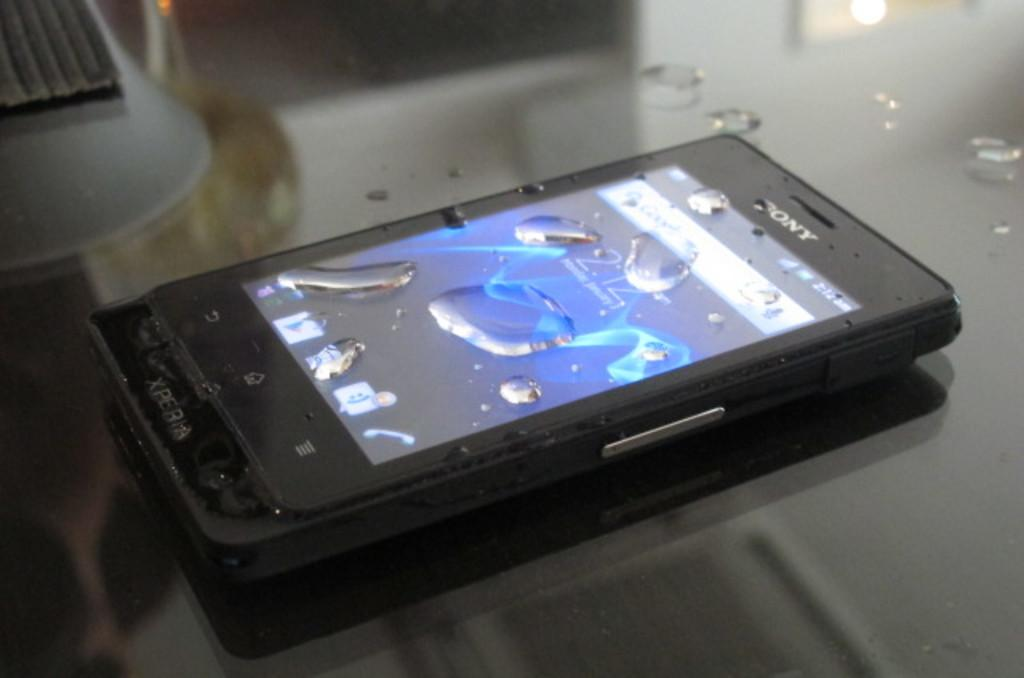What electronic device is visible in the image? There is a mobile phone in the image. Where is the mobile phone placed? The mobile phone is on a glass table. What can be seen on the surface of the mobile phone? There are droplets of water on the mobile phone. Can you describe the object on the left side top of the image? The clarity of the object is uncertain, so it is difficult to provide a detailed description. What arithmetic problem is being solved on the mobile phone in the image? There is no indication in the image that a mobile phone is being used to solve an arithmetic problem. What need is being addressed by the presence of the object on the left side top of the image? The purpose or need addressed by the object on the left side top of the image cannot be determined due to its uncertain clarity. 